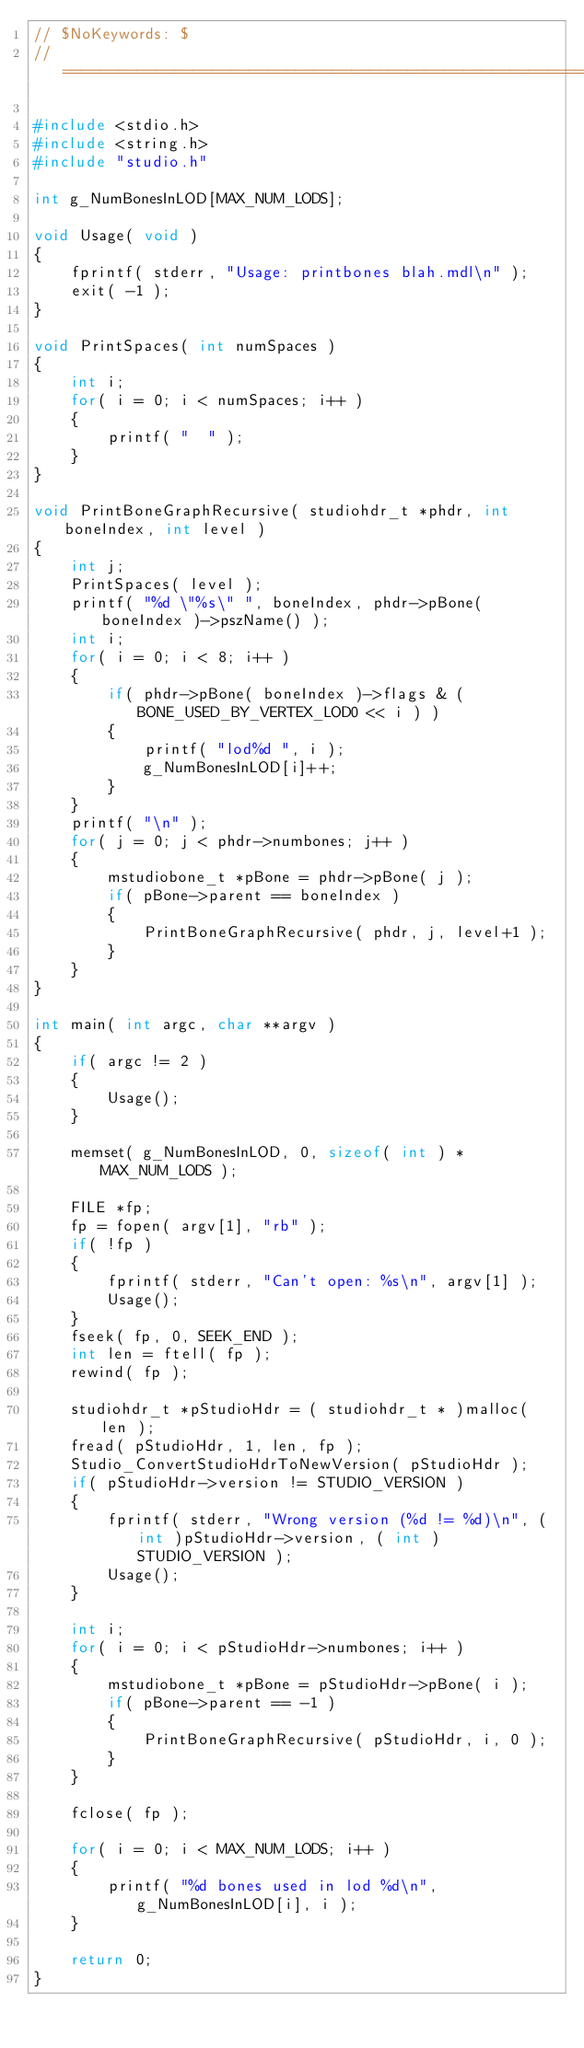Convert code to text. <code><loc_0><loc_0><loc_500><loc_500><_C++_>// $NoKeywords: $
//=============================================================================//

#include <stdio.h>
#include <string.h>
#include "studio.h"

int g_NumBonesInLOD[MAX_NUM_LODS];

void Usage( void )
{
	fprintf( stderr, "Usage: printbones blah.mdl\n" );
	exit( -1 );
}

void PrintSpaces( int numSpaces )
{
	int i;
	for( i = 0; i < numSpaces; i++ )
	{
		printf( "  " );
	}
}

void PrintBoneGraphRecursive( studiohdr_t *phdr, int boneIndex, int level )
{
	int j;
	PrintSpaces( level );
	printf( "%d \"%s\" ", boneIndex, phdr->pBone( boneIndex )->pszName() );
	int i;
	for( i = 0; i < 8; i++ )
	{
		if( phdr->pBone( boneIndex )->flags & ( BONE_USED_BY_VERTEX_LOD0 << i ) )
		{
			printf( "lod%d ", i );
			g_NumBonesInLOD[i]++;
		}
	}
	printf( "\n" );
	for( j = 0; j < phdr->numbones; j++ )
	{
		mstudiobone_t *pBone = phdr->pBone( j );
		if( pBone->parent == boneIndex )
		{
			PrintBoneGraphRecursive( phdr, j, level+1 );
		}
	}
}

int main( int argc, char **argv )
{
	if( argc != 2 )
	{
		Usage();
	}

	memset( g_NumBonesInLOD, 0, sizeof( int ) * MAX_NUM_LODS );
	
	FILE *fp;
	fp = fopen( argv[1], "rb" );
	if( !fp )
	{
		fprintf( stderr, "Can't open: %s\n", argv[1] );
		Usage();
	}
	fseek( fp, 0, SEEK_END );
	int len = ftell( fp );
	rewind( fp );

	studiohdr_t *pStudioHdr = ( studiohdr_t * )malloc( len );
	fread( pStudioHdr, 1, len, fp );
	Studio_ConvertStudioHdrToNewVersion( pStudioHdr );
	if( pStudioHdr->version != STUDIO_VERSION )
	{
		fprintf( stderr, "Wrong version (%d != %d)\n", ( int )pStudioHdr->version, ( int )STUDIO_VERSION );
		Usage();
	}

	int i;
	for( i = 0; i < pStudioHdr->numbones; i++ )
	{
		mstudiobone_t *pBone = pStudioHdr->pBone( i );
		if( pBone->parent == -1 )
		{
			PrintBoneGraphRecursive( pStudioHdr, i, 0 );
		}
	}
	
	fclose( fp );

	for( i = 0; i < MAX_NUM_LODS; i++ )
	{
		printf( "%d bones used in lod %d\n", g_NumBonesInLOD[i], i );
	}

	return 0;
}</code> 